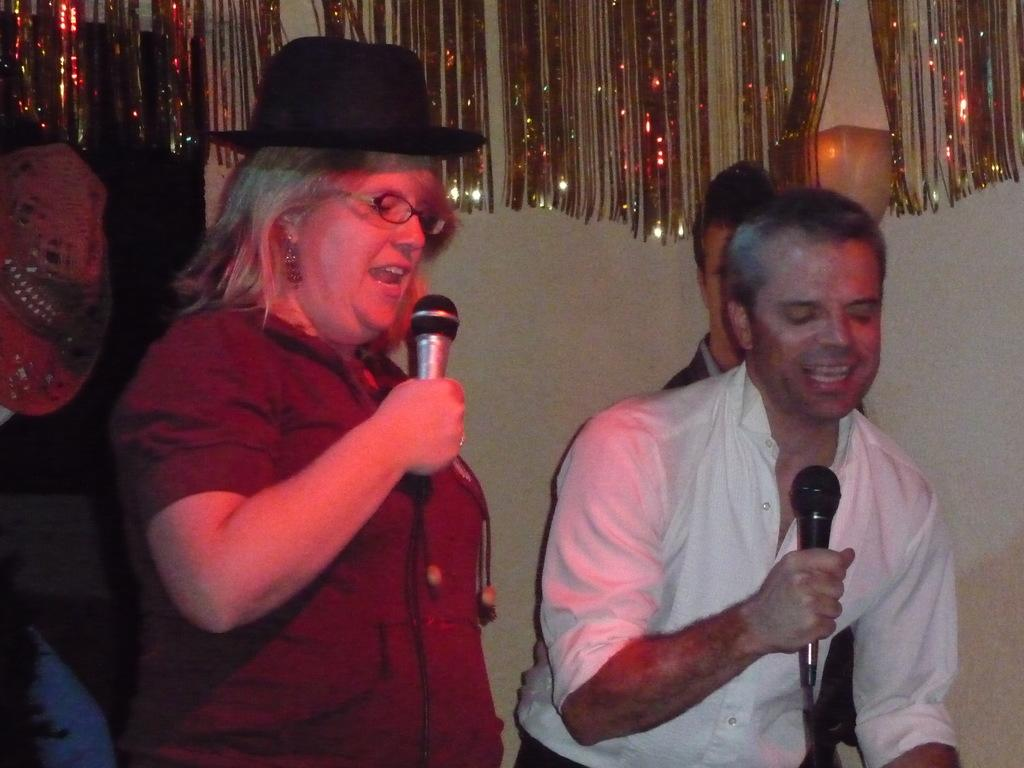What is the woman in the image doing? The woman is singing in the image. What object is the woman holding while singing? The woman is holding a microphone. Is there anyone else in the image besides the woman? Yes, there is a man in the image. What is the man in the image doing? The man is also singing in the image. What object is the man holding while singing? The man is holding a microphone. How many cows can be seen grazing in the background of the image? There are no cows present in the image; it features a woman and a man singing with microphones. 